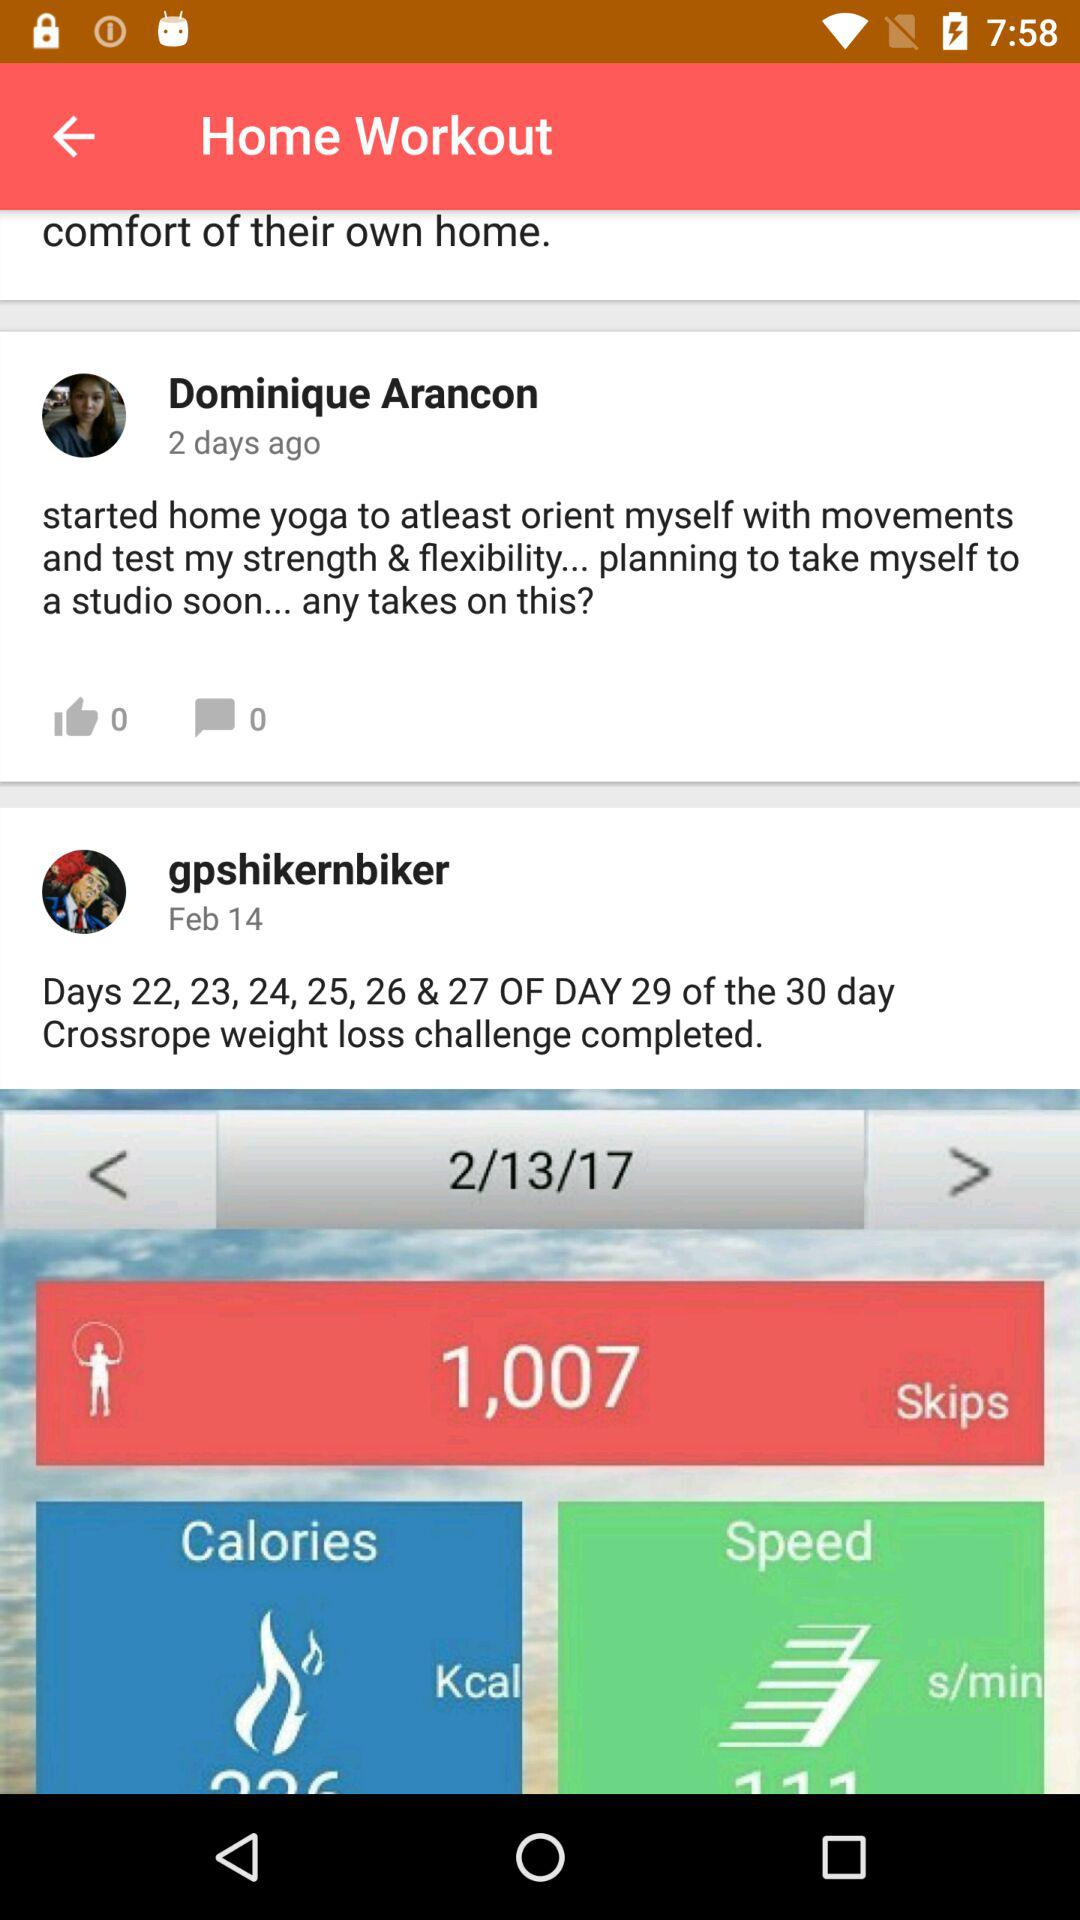How many likes did Dominique Arancon post get? There are 0 likes. 